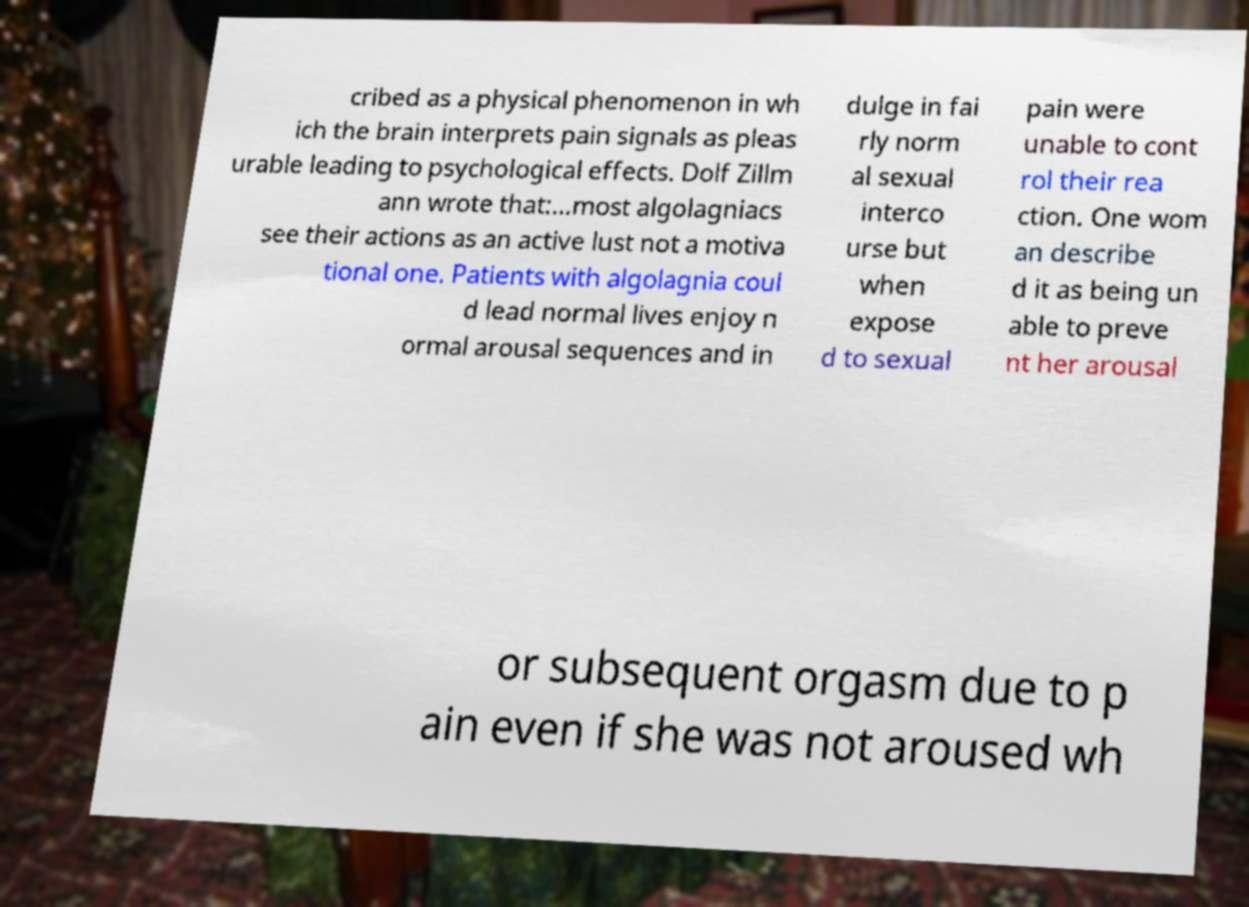Please identify and transcribe the text found in this image. cribed as a physical phenomenon in wh ich the brain interprets pain signals as pleas urable leading to psychological effects. Dolf Zillm ann wrote that:...most algolagniacs see their actions as an active lust not a motiva tional one. Patients with algolagnia coul d lead normal lives enjoy n ormal arousal sequences and in dulge in fai rly norm al sexual interco urse but when expose d to sexual pain were unable to cont rol their rea ction. One wom an describe d it as being un able to preve nt her arousal or subsequent orgasm due to p ain even if she was not aroused wh 